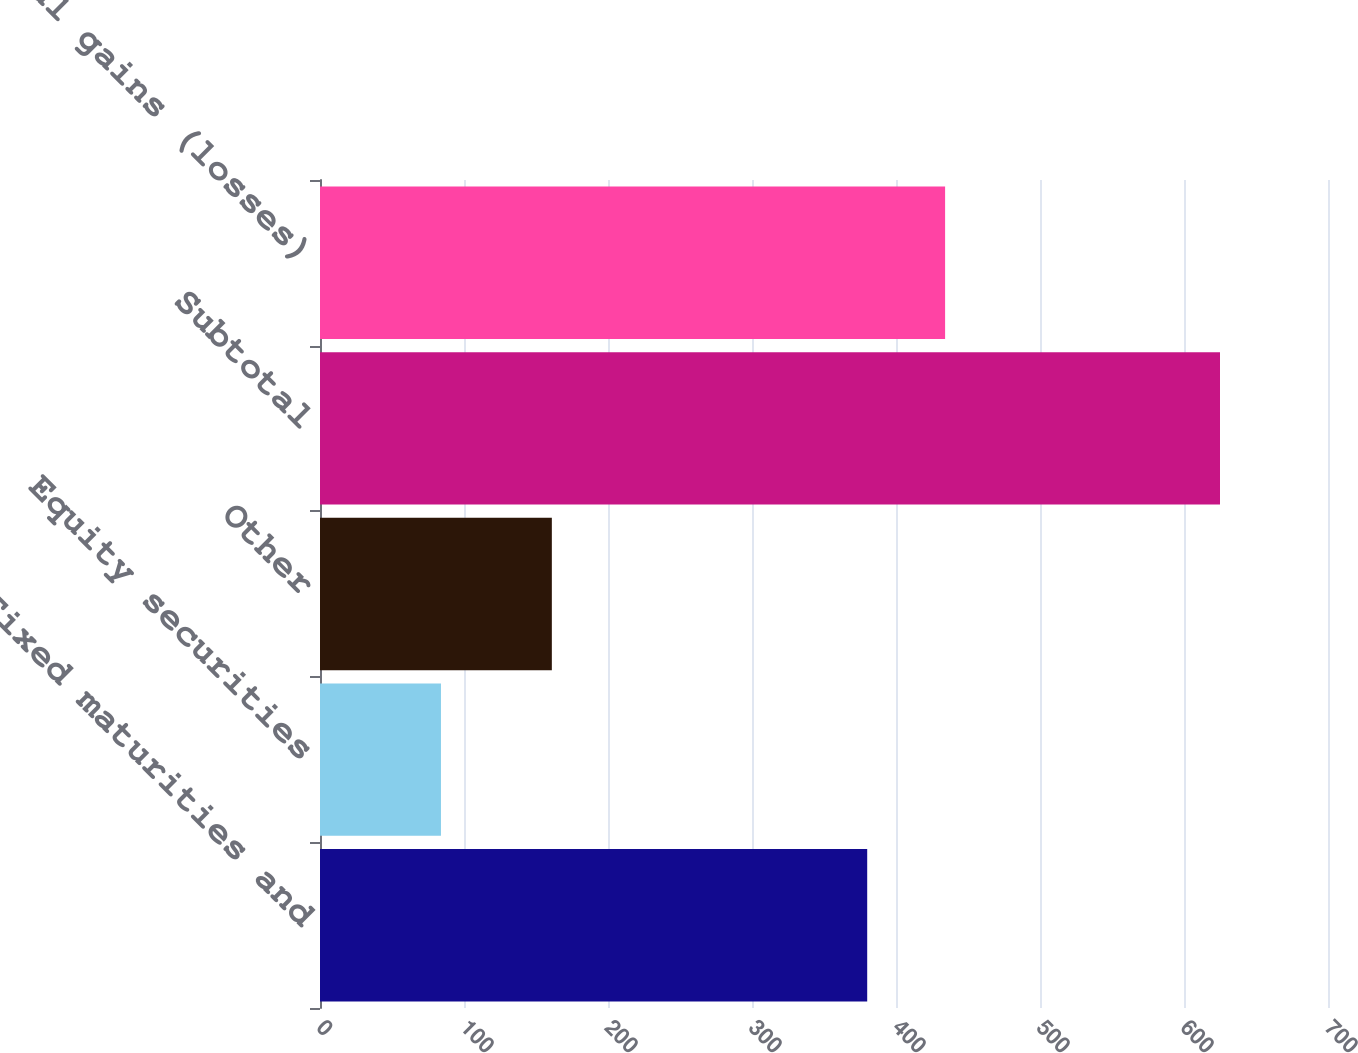<chart> <loc_0><loc_0><loc_500><loc_500><bar_chart><fcel>Fixed maturities and<fcel>Equity securities<fcel>Other<fcel>Subtotal<fcel>Total gains (losses)<nl><fcel>380<fcel>84<fcel>161<fcel>625<fcel>434.1<nl></chart> 